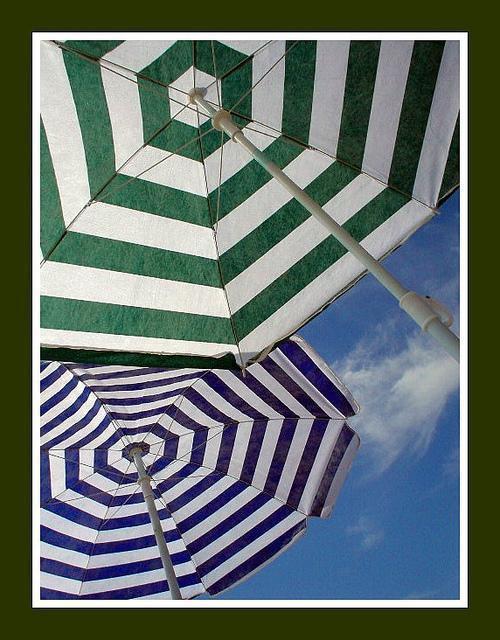How many umbrellas are seen?
Give a very brief answer. 2. How many umbrellas are in the picture?
Give a very brief answer. 2. 